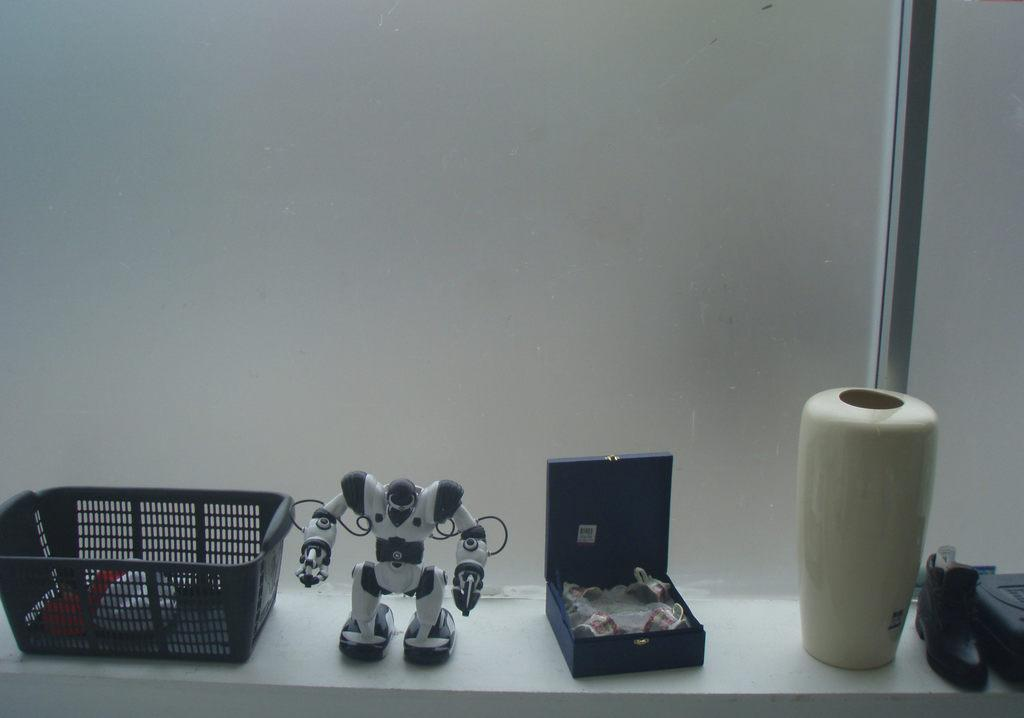What object is present in the image that can hold items? There is a basket in the image that can hold items. What type of toy can be seen in the image? There is a robot toy in the image. What is the base used for in the image? There is a base in the image, but its purpose is not specified. Where is the shoe located in the image? The shoe is on a platform in the image. What type of plant is growing near the robot toy in the image? There is no plant present in the image; it only features a basket, robot toy, base, and shoe on a platform. How does the brother interact with the robot toy in the image? There is no brother present in the image, so it is not possible to determine how they might interact with the robot toy. 